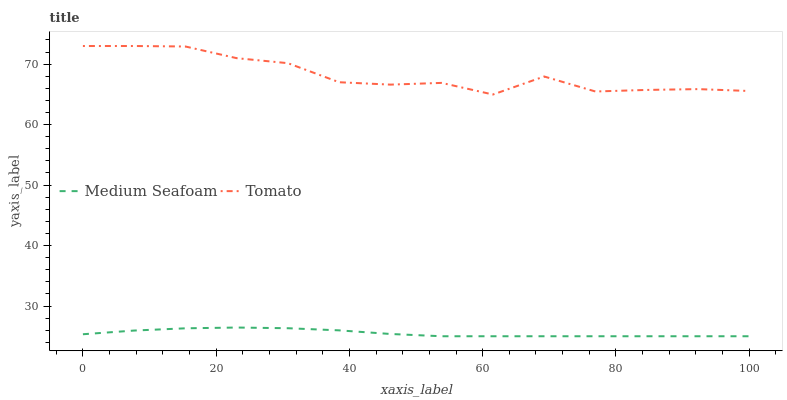Does Medium Seafoam have the maximum area under the curve?
Answer yes or no. No. Is Medium Seafoam the roughest?
Answer yes or no. No. Does Medium Seafoam have the highest value?
Answer yes or no. No. Is Medium Seafoam less than Tomato?
Answer yes or no. Yes. Is Tomato greater than Medium Seafoam?
Answer yes or no. Yes. Does Medium Seafoam intersect Tomato?
Answer yes or no. No. 